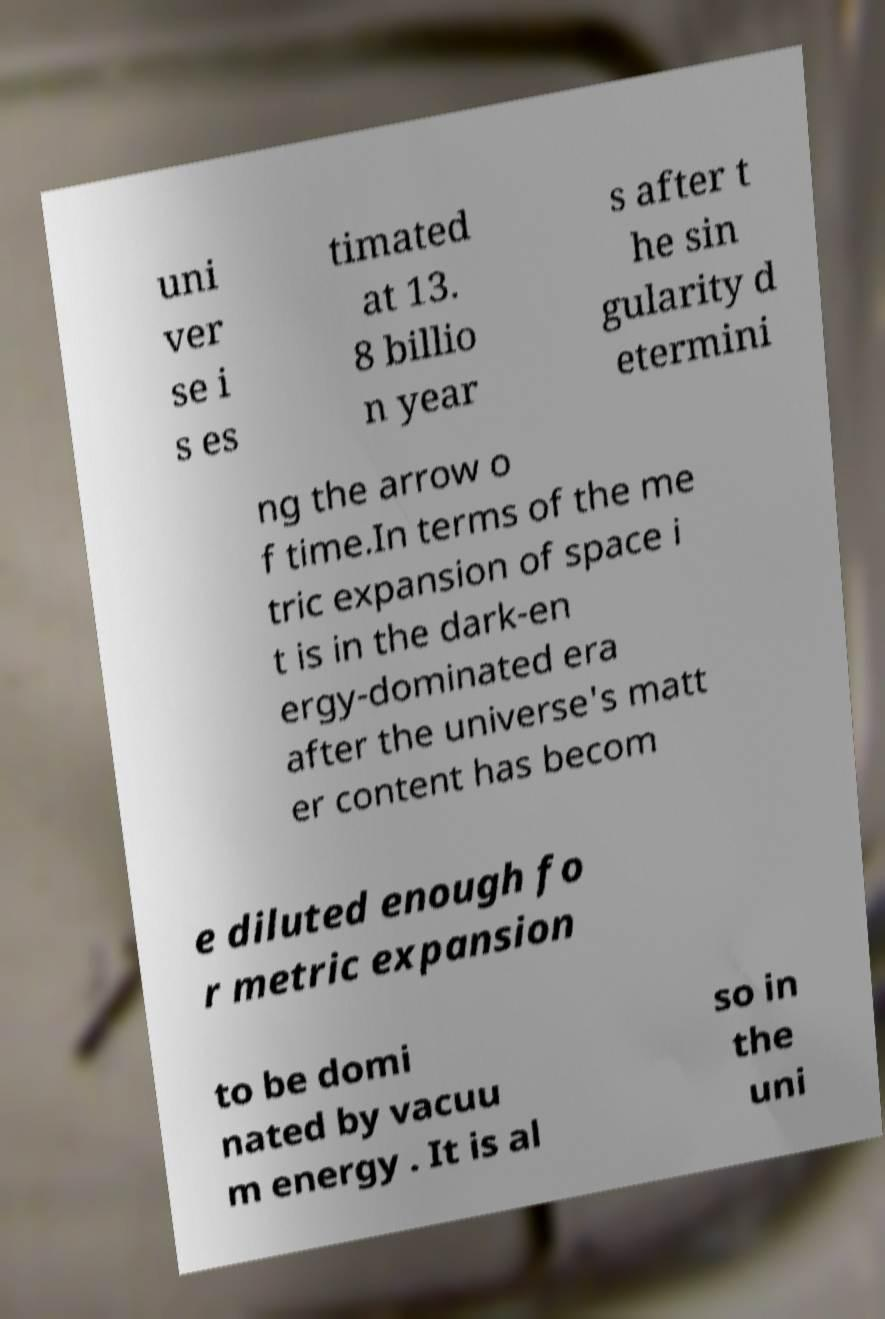For documentation purposes, I need the text within this image transcribed. Could you provide that? uni ver se i s es timated at 13. 8 billio n year s after t he sin gularity d etermini ng the arrow o f time.In terms of the me tric expansion of space i t is in the dark-en ergy-dominated era after the universe's matt er content has becom e diluted enough fo r metric expansion to be domi nated by vacuu m energy . It is al so in the uni 